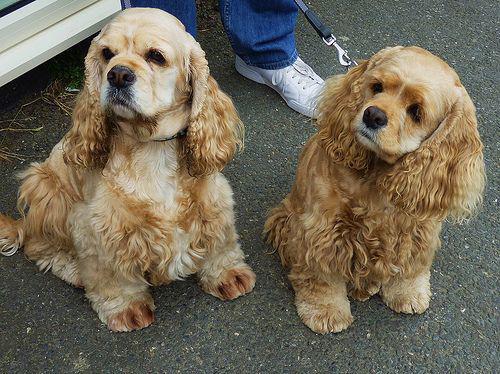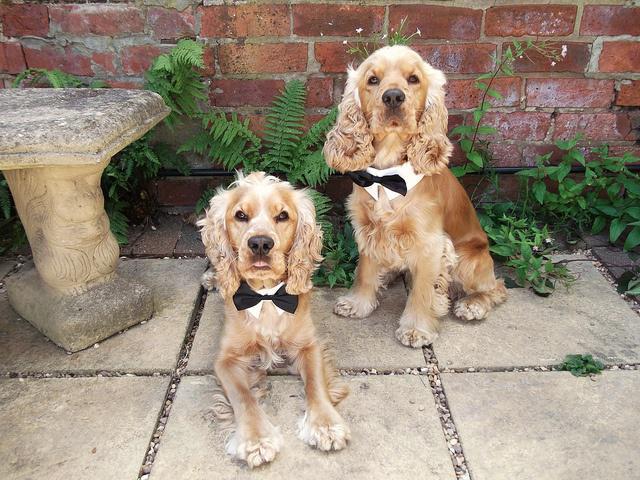The first image is the image on the left, the second image is the image on the right. Assess this claim about the two images: "Each image contains at least two cocker spaniels, and at least one image shows cocker spaniels sitting upright and looking upward.". Correct or not? Answer yes or no. Yes. The first image is the image on the left, the second image is the image on the right. Considering the images on both sides, is "The image on the right contains exactly two dogs." valid? Answer yes or no. Yes. 